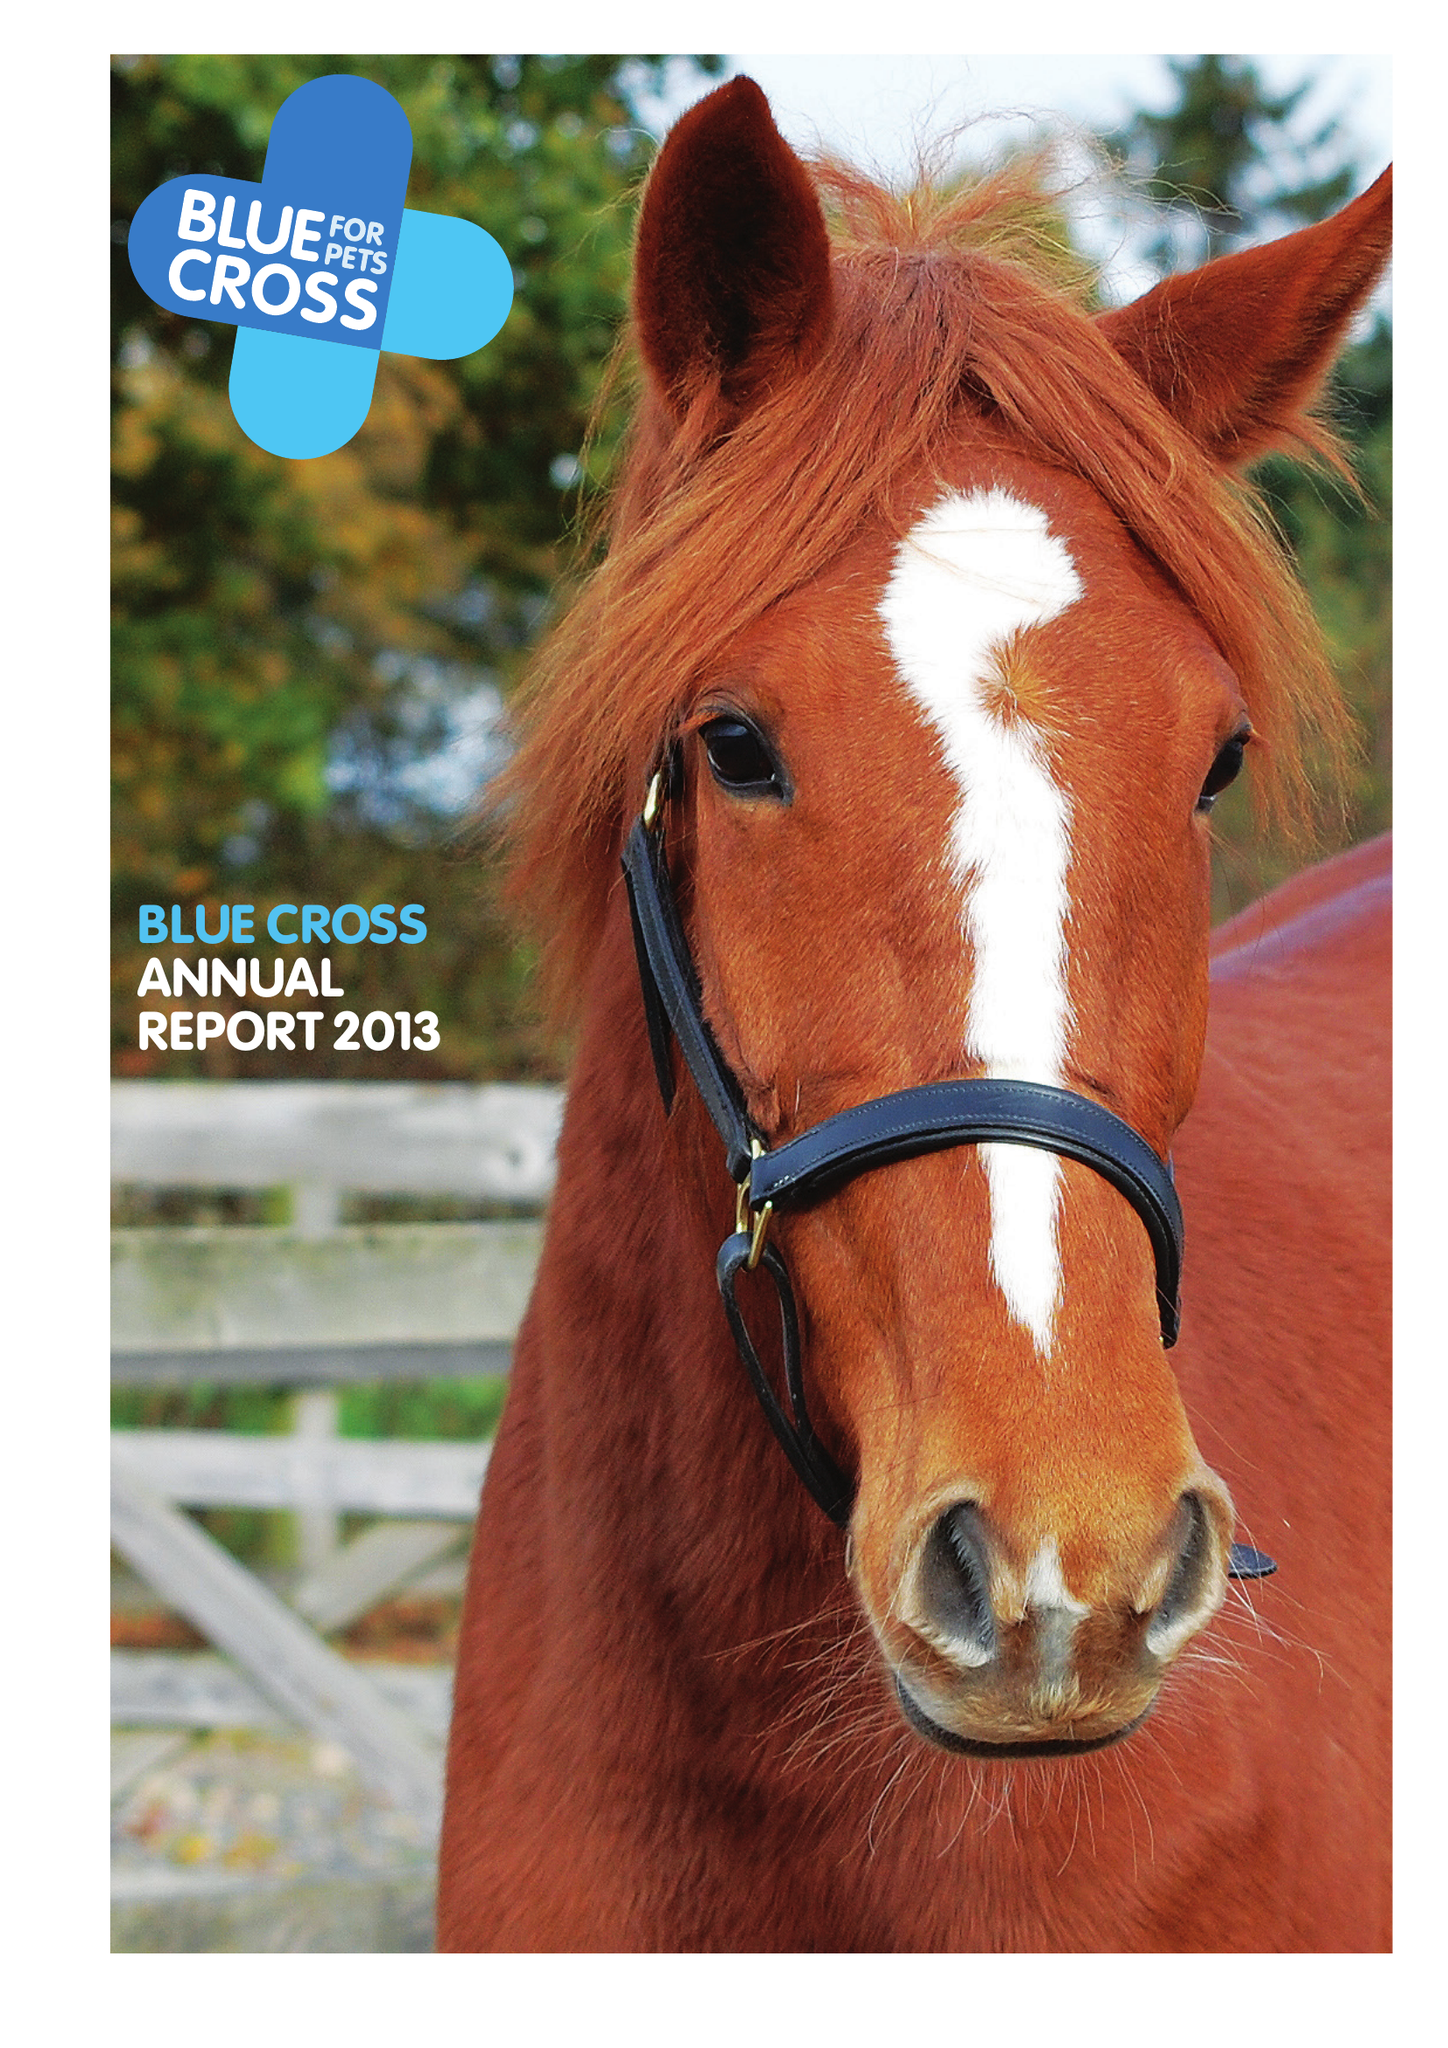What is the value for the spending_annually_in_british_pounds?
Answer the question using a single word or phrase. 31571000.00 